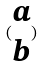<formula> <loc_0><loc_0><loc_500><loc_500>( \begin{matrix} a \\ b \end{matrix} )</formula> 